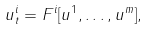<formula> <loc_0><loc_0><loc_500><loc_500>u ^ { i } _ { t } = F ^ { i } [ u ^ { 1 } , \dots , u ^ { m } ] ,</formula> 